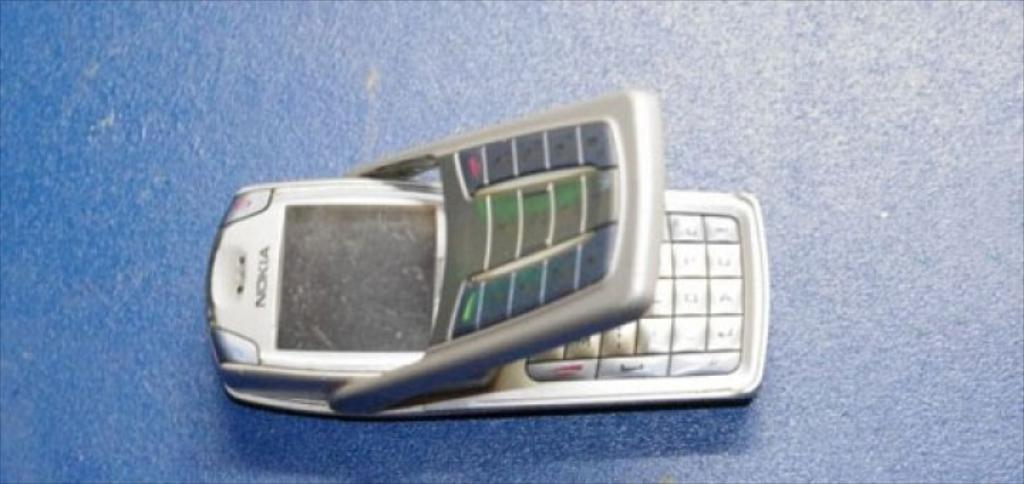<image>
Create a compact narrative representing the image presented. A silver Nokia flip phone open displaying a second keypad 